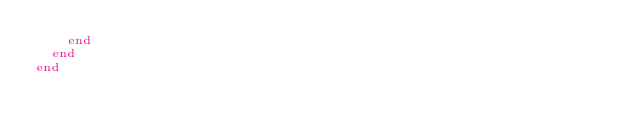<code> <loc_0><loc_0><loc_500><loc_500><_Ruby_>    end
  end
end
</code> 